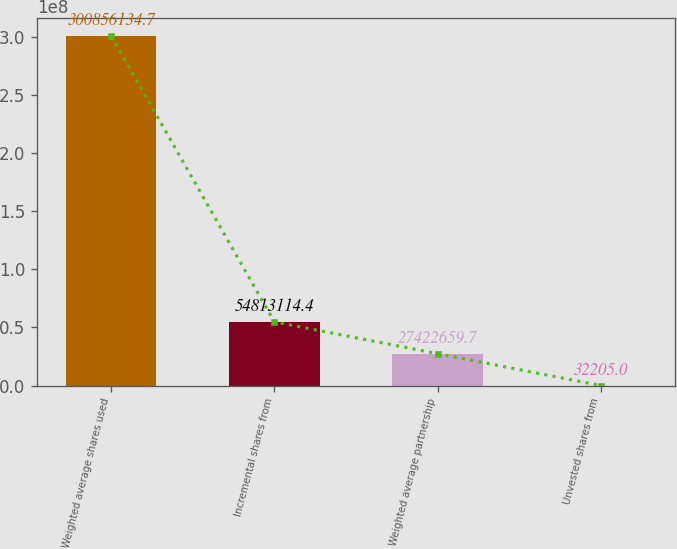Convert chart. <chart><loc_0><loc_0><loc_500><loc_500><bar_chart><fcel>Weighted average shares used<fcel>Incremental shares from<fcel>Weighted average partnership<fcel>Unvested shares from<nl><fcel>3.00856e+08<fcel>5.48131e+07<fcel>2.74227e+07<fcel>32205<nl></chart> 